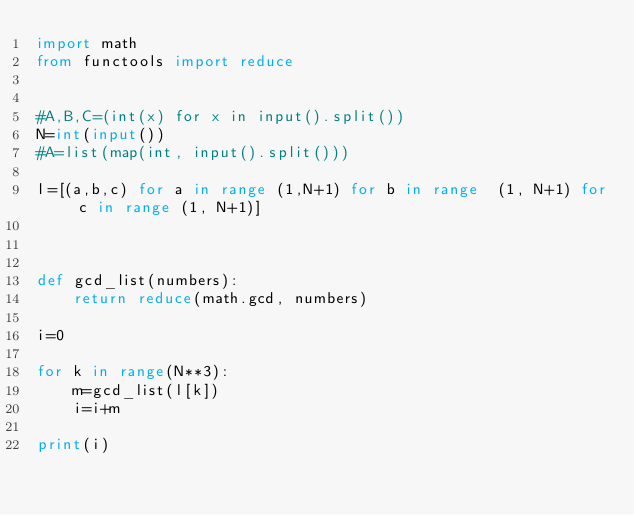Convert code to text. <code><loc_0><loc_0><loc_500><loc_500><_Python_>import math
from functools import reduce


#A,B,C=(int(x) for x in input().split())
N=int(input())
#A=list(map(int, input().split()))

l=[(a,b,c) for a in range (1,N+1) for b in range  (1, N+1) for c in range (1, N+1)]



def gcd_list(numbers):
    return reduce(math.gcd, numbers)

i=0

for k in range(N**3):
    m=gcd_list(l[k])
    i=i+m
    
print(i)</code> 